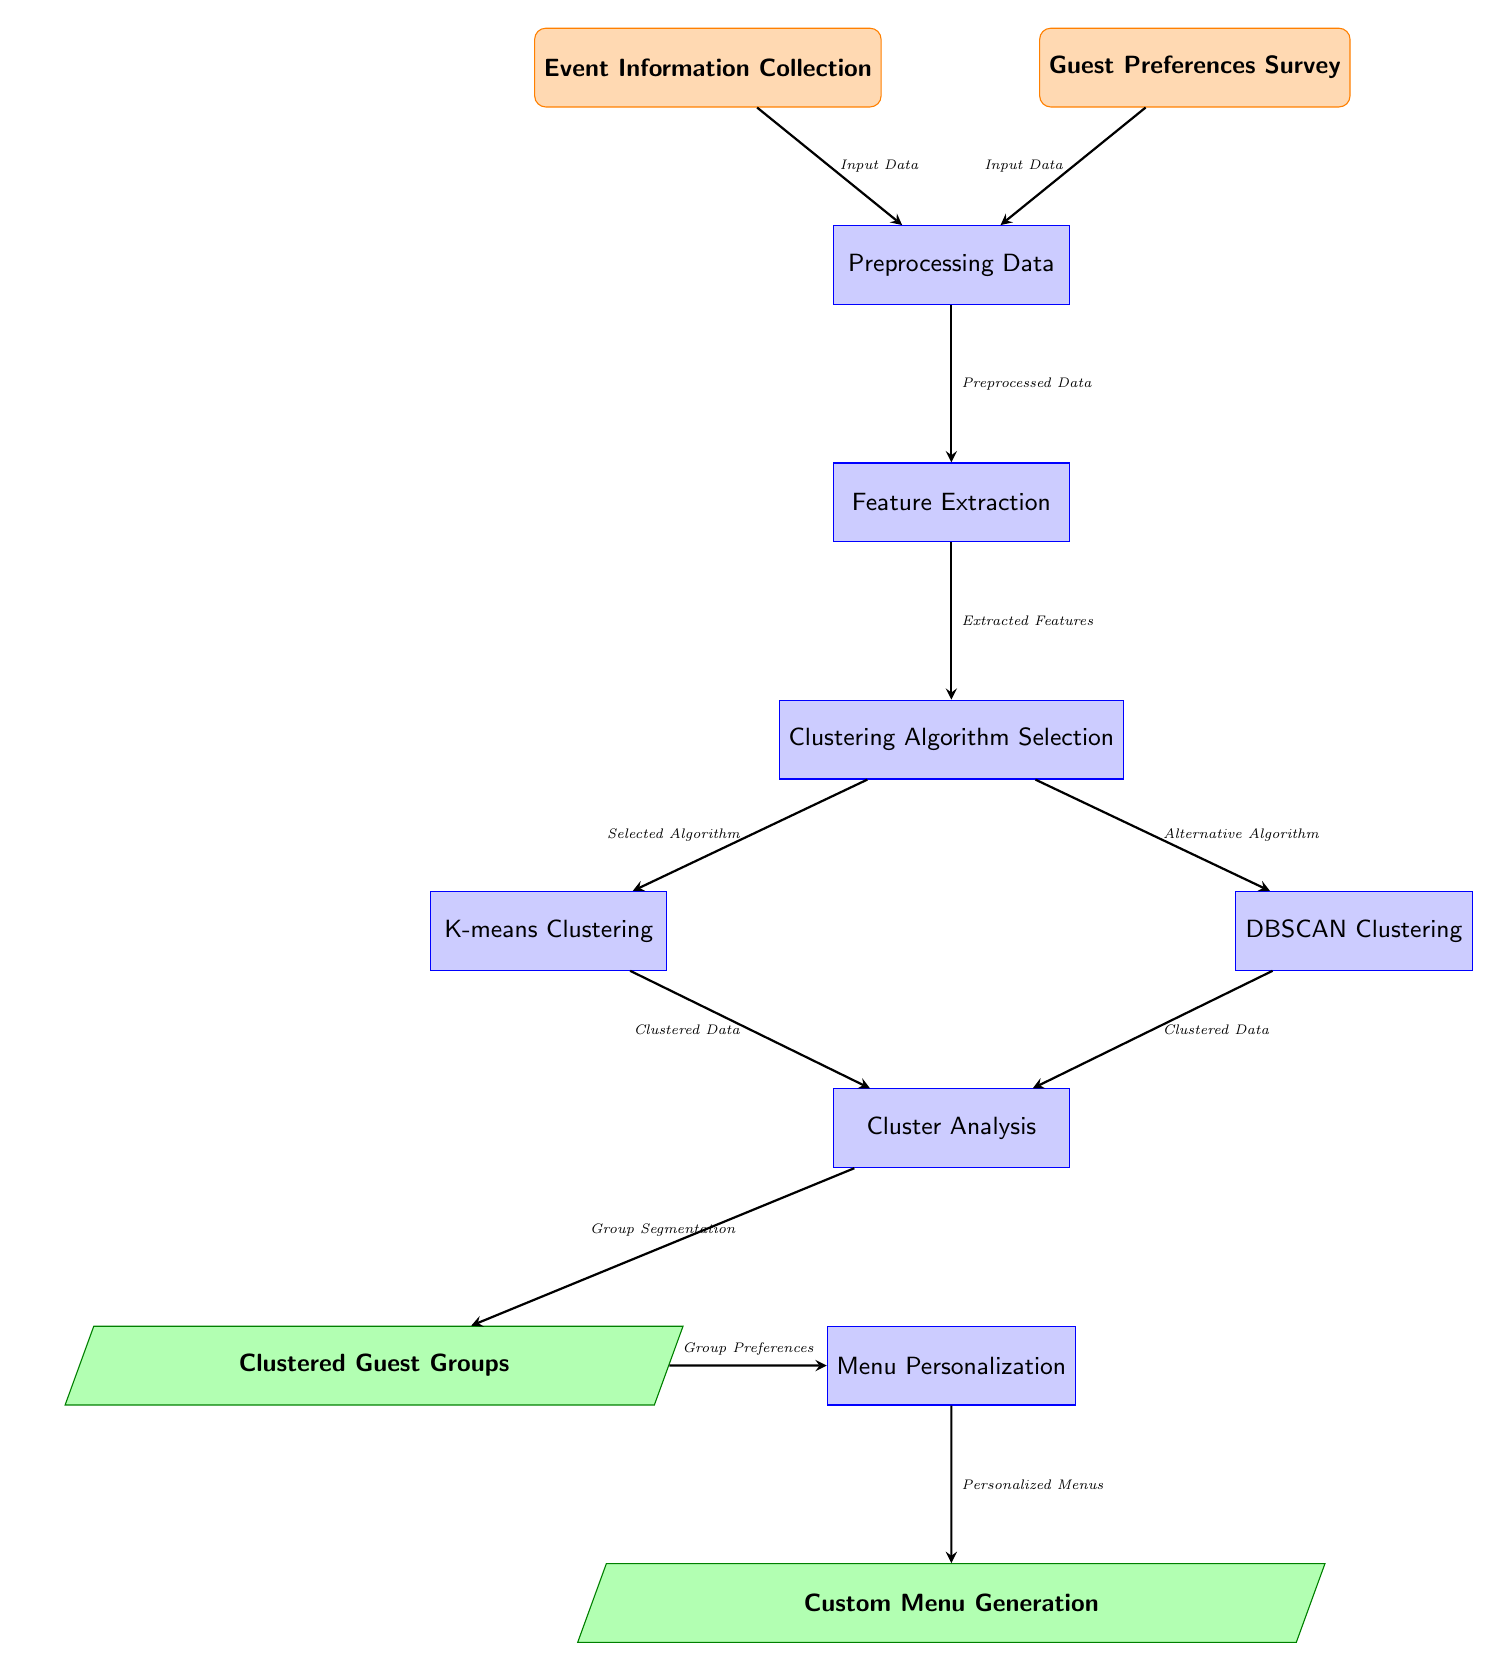What are the two input nodes in the diagram? The two input nodes identified in the diagram are "Event Information Collection" and "Guest Preferences Survey" as they are the first two boxes in the diagram.
Answer: Event Information Collection, Guest Preferences Survey How many process nodes are there in total? There are six process nodes in total, which are "Preprocessing Data," "Feature Extraction," "Clustering Algorithm Selection," "K-means Clustering," "DBSCAN Clustering," and "Cluster Analysis."
Answer: Six What kind of output is generated from the "Menu Personalization" process node? The output generated from the "Menu Personalization" process node is depicted as "Custom Menu Generation," which is directly below the personalization process in the diagram.
Answer: Custom Menu Generation Which process node follows after "Feature Extraction"? The process node that follows after "Feature Extraction" is "Clustering Algorithm Selection," as indicated by the flow arrows connecting the nodes in sequence.
Answer: Clustering Algorithm Selection What two clustering algorithms are listed in the diagram? The two clustering algorithms listed in the diagram are "K-means Clustering" and "DBSCAN Clustering," which are positioned beneath the "Clustering Algorithm Selection" node.
Answer: K-means Clustering, DBSCAN Clustering How does the "Guest Preferences Survey" relate to the preprocessing step? The "Guest Preferences Survey" node is directed towards the "Preprocessing Data" node, indicating that it contributes input data along with the "Event Information Collection" to this subsequent process.
Answer: Input Data What is the purpose of the "Cluster Analysis" process node? The purpose of the "Cluster Analysis" process node is to analyze the clustered data produced by either the K-means or DBSCAN clustering, hence facilitating understanding of group preferences as part of the workflow.
Answer: Group Segmentation Which node symbolizes the segmented guest groups? The node that symbolizes the segmented guest groups is labeled "Clustered Guest Groups," situated to the left of the "Menu Personalization" node, indicating the result of cluster analysis.
Answer: Clustered Guest Groups How many arrows are there in total connecting the nodes? There are eight arrows in total connecting the nodes, as they show the flow of data from the input to the output in the diagram.
Answer: Eight 